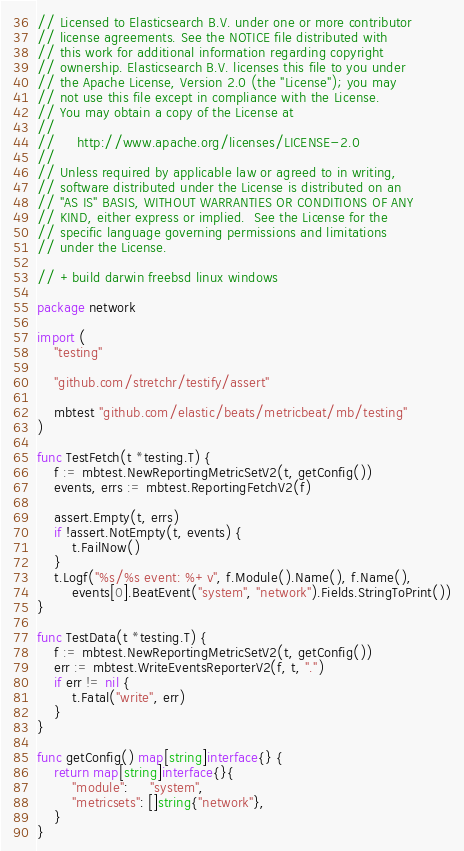Convert code to text. <code><loc_0><loc_0><loc_500><loc_500><_Go_>// Licensed to Elasticsearch B.V. under one or more contributor
// license agreements. See the NOTICE file distributed with
// this work for additional information regarding copyright
// ownership. Elasticsearch B.V. licenses this file to you under
// the Apache License, Version 2.0 (the "License"); you may
// not use this file except in compliance with the License.
// You may obtain a copy of the License at
//
//     http://www.apache.org/licenses/LICENSE-2.0
//
// Unless required by applicable law or agreed to in writing,
// software distributed under the License is distributed on an
// "AS IS" BASIS, WITHOUT WARRANTIES OR CONDITIONS OF ANY
// KIND, either express or implied.  See the License for the
// specific language governing permissions and limitations
// under the License.

// +build darwin freebsd linux windows

package network

import (
	"testing"

	"github.com/stretchr/testify/assert"

	mbtest "github.com/elastic/beats/metricbeat/mb/testing"
)

func TestFetch(t *testing.T) {
	f := mbtest.NewReportingMetricSetV2(t, getConfig())
	events, errs := mbtest.ReportingFetchV2(f)

	assert.Empty(t, errs)
	if !assert.NotEmpty(t, events) {
		t.FailNow()
	}
	t.Logf("%s/%s event: %+v", f.Module().Name(), f.Name(),
		events[0].BeatEvent("system", "network").Fields.StringToPrint())
}

func TestData(t *testing.T) {
	f := mbtest.NewReportingMetricSetV2(t, getConfig())
	err := mbtest.WriteEventsReporterV2(f, t, ".")
	if err != nil {
		t.Fatal("write", err)
	}
}

func getConfig() map[string]interface{} {
	return map[string]interface{}{
		"module":     "system",
		"metricsets": []string{"network"},
	}
}
</code> 